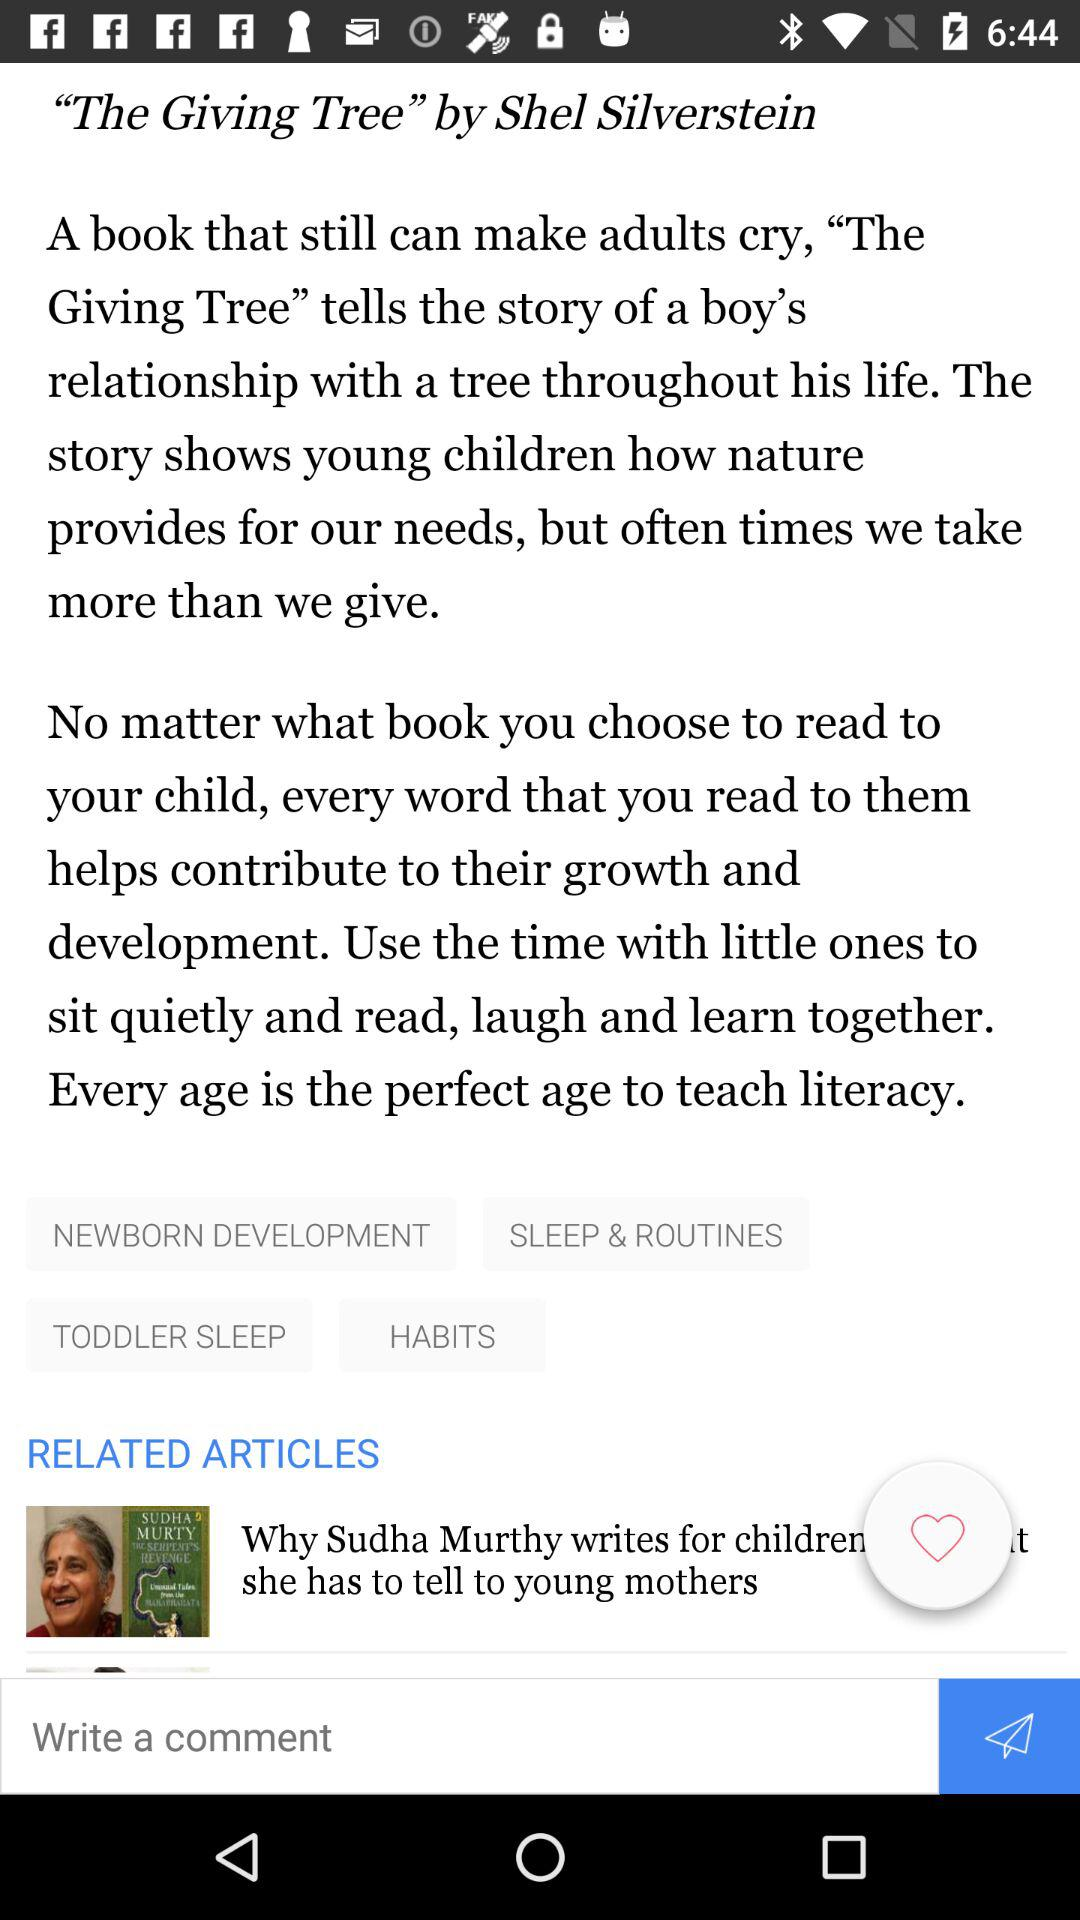By whom is the article written? The article is written by Shel Silverstein. 